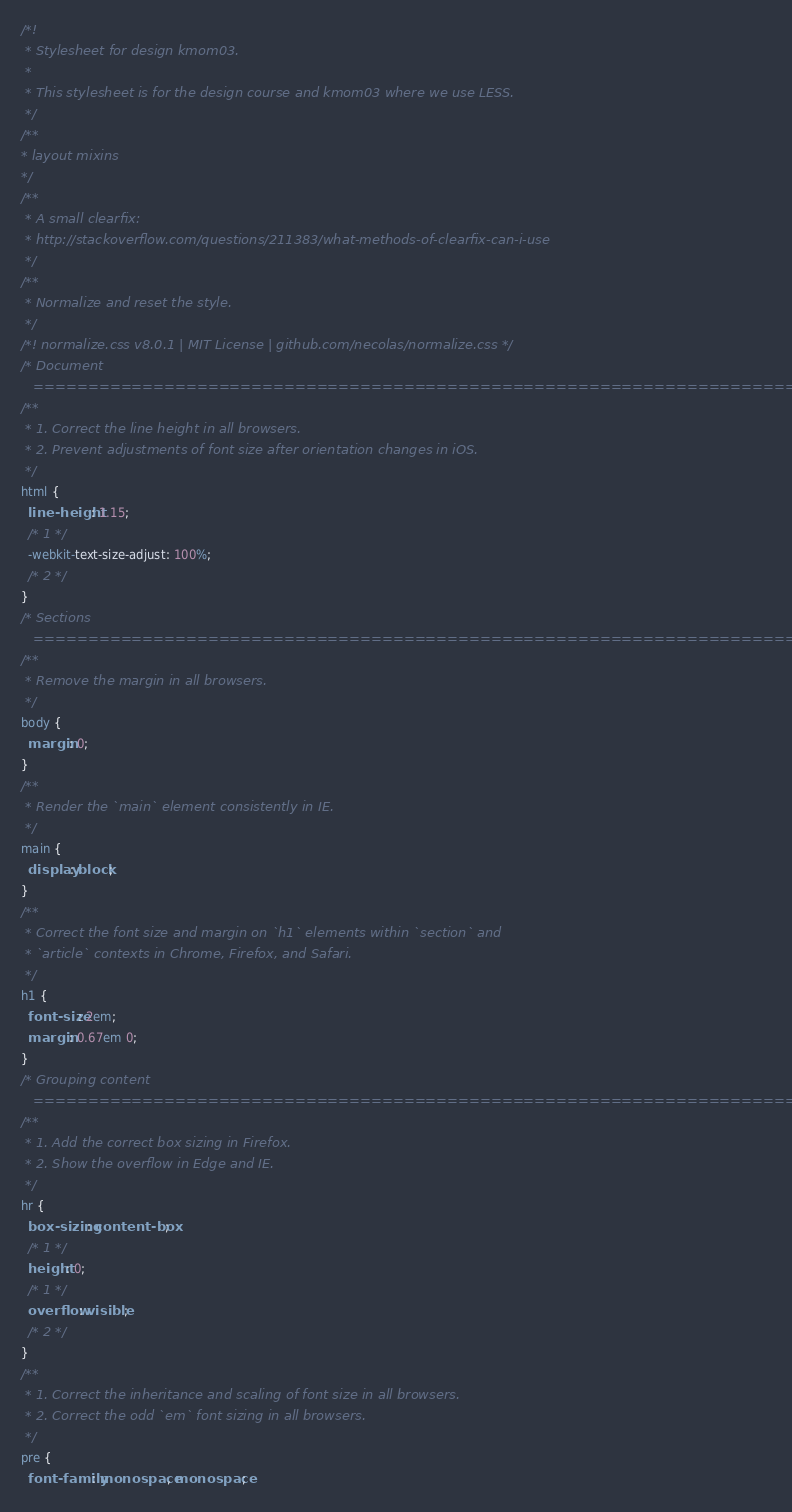Convert code to text. <code><loc_0><loc_0><loc_500><loc_500><_CSS_>/*!
 * Stylesheet for design kmom03.
 *
 * This stylesheet is for the design course and kmom03 where we use LESS.
 */
/**
* layout mixins
*/
/**
 * A small clearfix:
 * http://stackoverflow.com/questions/211383/what-methods-of-clearfix-can-i-use
 */
/**
 * Normalize and reset the style.
 */
/*! normalize.css v8.0.1 | MIT License | github.com/necolas/normalize.css */
/* Document
   ========================================================================== */
/**
 * 1. Correct the line height in all browsers.
 * 2. Prevent adjustments of font size after orientation changes in iOS.
 */
html {
  line-height: 1.15;
  /* 1 */
  -webkit-text-size-adjust: 100%;
  /* 2 */
}
/* Sections
   ========================================================================== */
/**
 * Remove the margin in all browsers.
 */
body {
  margin: 0;
}
/**
 * Render the `main` element consistently in IE.
 */
main {
  display: block;
}
/**
 * Correct the font size and margin on `h1` elements within `section` and
 * `article` contexts in Chrome, Firefox, and Safari.
 */
h1 {
  font-size: 2em;
  margin: 0.67em 0;
}
/* Grouping content
   ========================================================================== */
/**
 * 1. Add the correct box sizing in Firefox.
 * 2. Show the overflow in Edge and IE.
 */
hr {
  box-sizing: content-box;
  /* 1 */
  height: 0;
  /* 1 */
  overflow: visible;
  /* 2 */
}
/**
 * 1. Correct the inheritance and scaling of font size in all browsers.
 * 2. Correct the odd `em` font sizing in all browsers.
 */
pre {
  font-family: monospace, monospace;</code> 